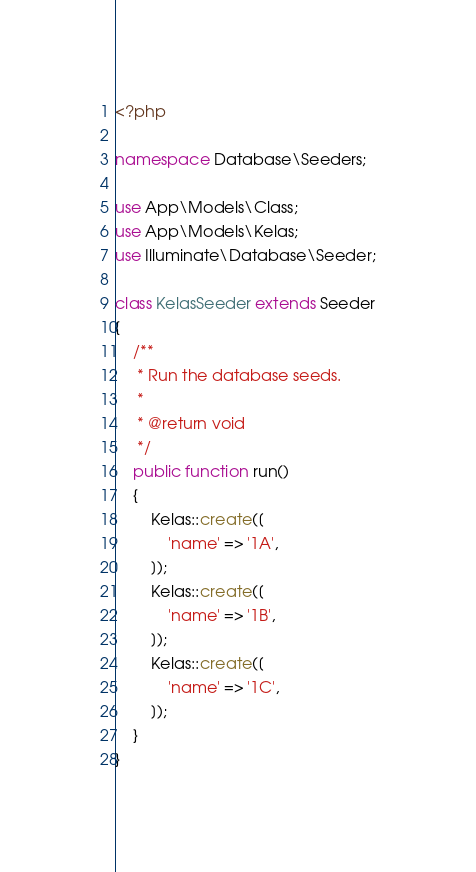Convert code to text. <code><loc_0><loc_0><loc_500><loc_500><_PHP_><?php

namespace Database\Seeders;

use App\Models\Class;
use App\Models\Kelas;
use Illuminate\Database\Seeder;

class KelasSeeder extends Seeder
{
    /**
     * Run the database seeds.
     *
     * @return void
     */
    public function run()
    {
        Kelas::create([
            'name' => '1A',
        ]);
        Kelas::create([
            'name' => '1B',
        ]);
        Kelas::create([
            'name' => '1C',
        ]);
    }
}
</code> 